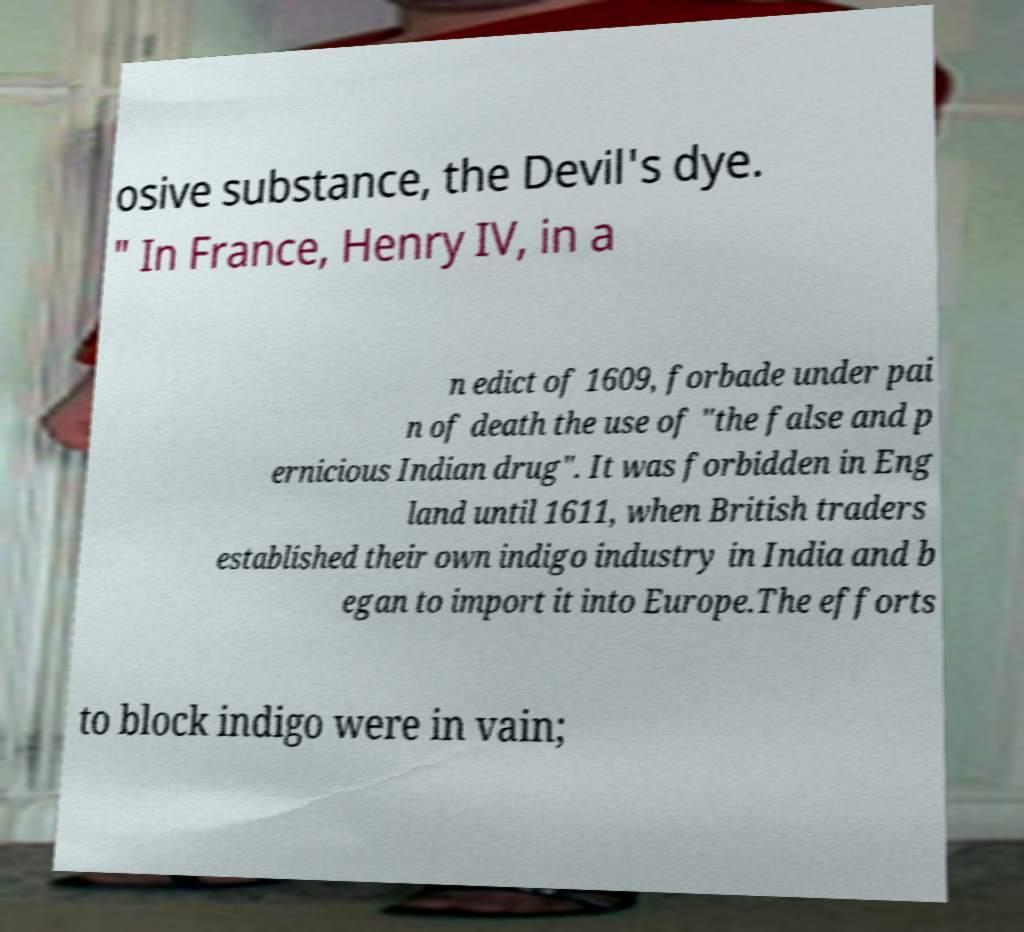Please identify and transcribe the text found in this image. osive substance, the Devil's dye. " In France, Henry IV, in a n edict of 1609, forbade under pai n of death the use of "the false and p ernicious Indian drug". It was forbidden in Eng land until 1611, when British traders established their own indigo industry in India and b egan to import it into Europe.The efforts to block indigo were in vain; 